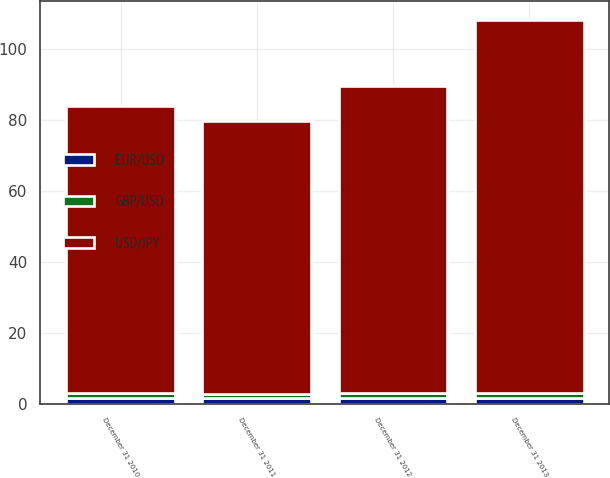Convert chart. <chart><loc_0><loc_0><loc_500><loc_500><stacked_bar_chart><ecel><fcel>December 31 2010<fcel>December 31 2011<fcel>December 31 2012<fcel>December 31 2013<nl><fcel>EUR/USD<fcel>1.56<fcel>1.55<fcel>1.62<fcel>1.66<nl><fcel>GBP/USD<fcel>1.34<fcel>1.3<fcel>1.32<fcel>1.38<nl><fcel>USD/JPY<fcel>81.22<fcel>76.92<fcel>86.73<fcel>105.26<nl></chart> 